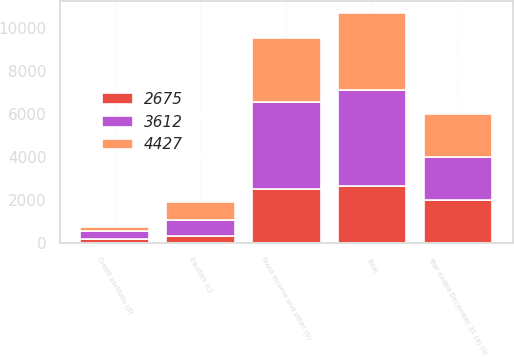Convert chart to OTSL. <chart><loc_0><loc_0><loc_500><loc_500><stacked_bar_chart><ecel><fcel>Year ended December 31 (a) (in<fcel>Fixed income and other (b)<fcel>Equities (c)<fcel>Credit portfolio (d)<fcel>Total<nl><fcel>4427<fcel>2004<fcel>2976<fcel>797<fcel>161<fcel>3612<nl><fcel>3612<fcel>2003<fcel>4046<fcel>764<fcel>383<fcel>4427<nl><fcel>2675<fcel>2002<fcel>2527<fcel>331<fcel>183<fcel>2675<nl></chart> 